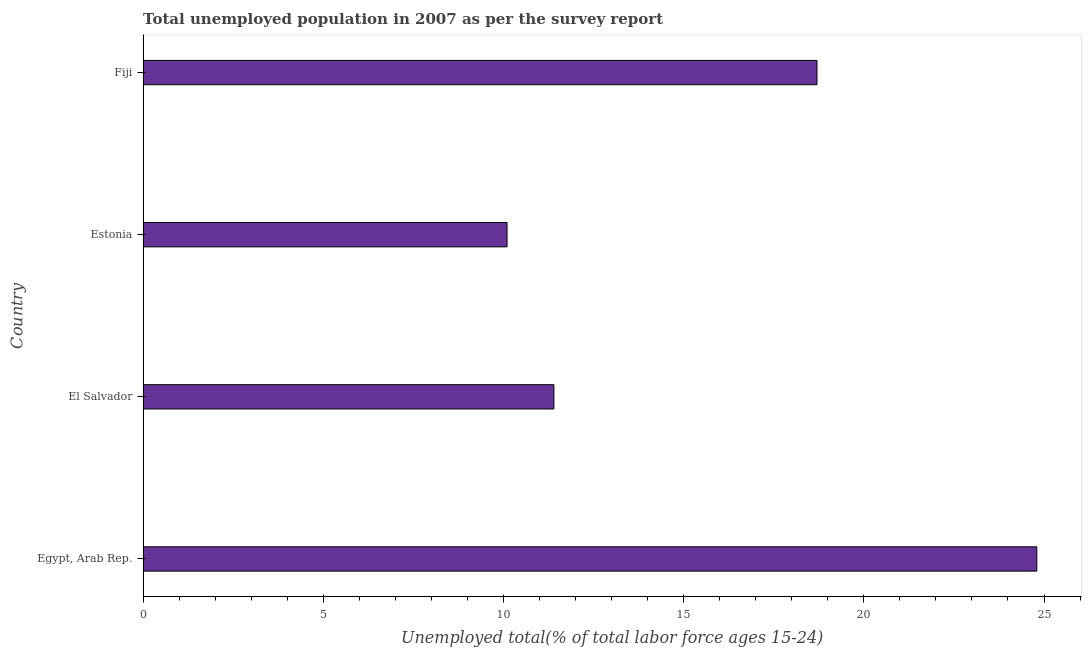What is the title of the graph?
Make the answer very short. Total unemployed population in 2007 as per the survey report. What is the label or title of the X-axis?
Keep it short and to the point. Unemployed total(% of total labor force ages 15-24). What is the unemployed youth in Fiji?
Give a very brief answer. 18.7. Across all countries, what is the maximum unemployed youth?
Ensure brevity in your answer.  24.8. Across all countries, what is the minimum unemployed youth?
Give a very brief answer. 10.1. In which country was the unemployed youth maximum?
Provide a succinct answer. Egypt, Arab Rep. In which country was the unemployed youth minimum?
Make the answer very short. Estonia. What is the sum of the unemployed youth?
Provide a short and direct response. 65. What is the average unemployed youth per country?
Your answer should be compact. 16.25. What is the median unemployed youth?
Give a very brief answer. 15.05. What is the ratio of the unemployed youth in Egypt, Arab Rep. to that in Fiji?
Your response must be concise. 1.33. Is the difference between the unemployed youth in Egypt, Arab Rep. and El Salvador greater than the difference between any two countries?
Your answer should be very brief. No. Is the sum of the unemployed youth in El Salvador and Estonia greater than the maximum unemployed youth across all countries?
Offer a terse response. No. What is the difference between the highest and the lowest unemployed youth?
Provide a short and direct response. 14.7. In how many countries, is the unemployed youth greater than the average unemployed youth taken over all countries?
Your answer should be compact. 2. How many bars are there?
Your answer should be compact. 4. How many countries are there in the graph?
Provide a succinct answer. 4. What is the Unemployed total(% of total labor force ages 15-24) in Egypt, Arab Rep.?
Keep it short and to the point. 24.8. What is the Unemployed total(% of total labor force ages 15-24) in El Salvador?
Your answer should be compact. 11.4. What is the Unemployed total(% of total labor force ages 15-24) in Estonia?
Your answer should be very brief. 10.1. What is the Unemployed total(% of total labor force ages 15-24) in Fiji?
Offer a very short reply. 18.7. What is the difference between the Unemployed total(% of total labor force ages 15-24) in Egypt, Arab Rep. and El Salvador?
Your response must be concise. 13.4. What is the difference between the Unemployed total(% of total labor force ages 15-24) in El Salvador and Fiji?
Keep it short and to the point. -7.3. What is the ratio of the Unemployed total(% of total labor force ages 15-24) in Egypt, Arab Rep. to that in El Salvador?
Offer a terse response. 2.17. What is the ratio of the Unemployed total(% of total labor force ages 15-24) in Egypt, Arab Rep. to that in Estonia?
Make the answer very short. 2.46. What is the ratio of the Unemployed total(% of total labor force ages 15-24) in Egypt, Arab Rep. to that in Fiji?
Your answer should be very brief. 1.33. What is the ratio of the Unemployed total(% of total labor force ages 15-24) in El Salvador to that in Estonia?
Give a very brief answer. 1.13. What is the ratio of the Unemployed total(% of total labor force ages 15-24) in El Salvador to that in Fiji?
Offer a terse response. 0.61. What is the ratio of the Unemployed total(% of total labor force ages 15-24) in Estonia to that in Fiji?
Make the answer very short. 0.54. 